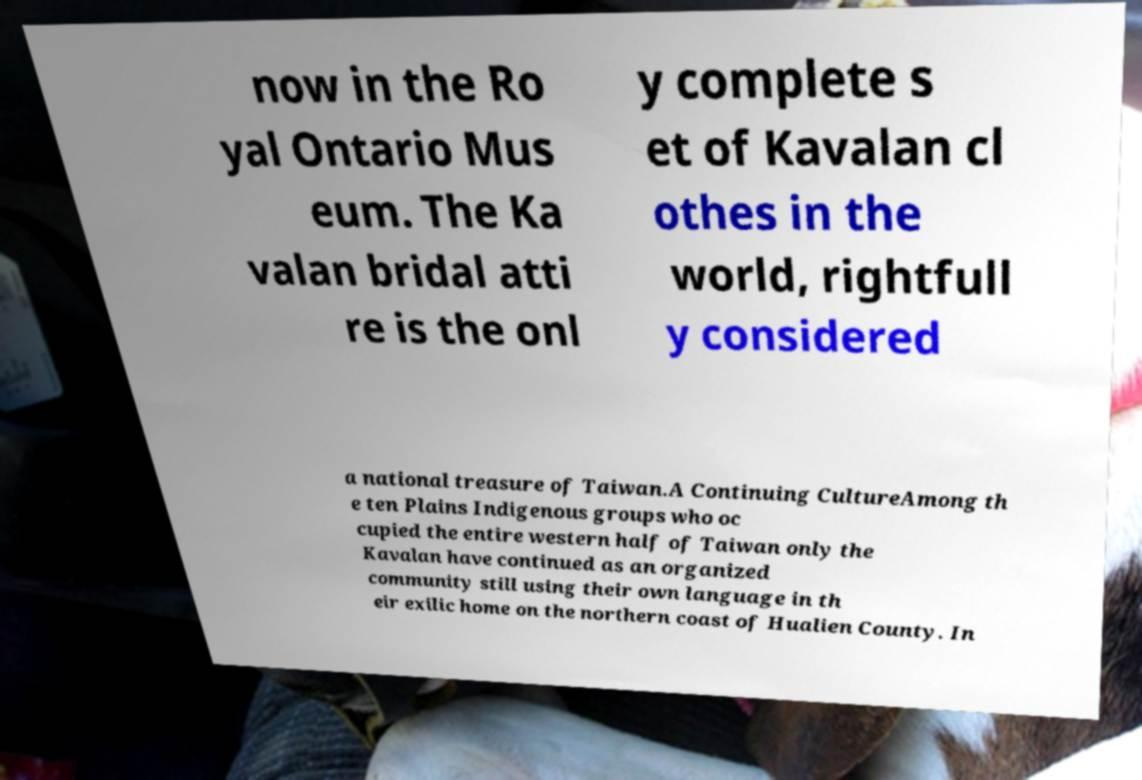Could you extract and type out the text from this image? now in the Ro yal Ontario Mus eum. The Ka valan bridal atti re is the onl y complete s et of Kavalan cl othes in the world, rightfull y considered a national treasure of Taiwan.A Continuing CultureAmong th e ten Plains Indigenous groups who oc cupied the entire western half of Taiwan only the Kavalan have continued as an organized community still using their own language in th eir exilic home on the northern coast of Hualien County. In 